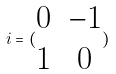Convert formula to latex. <formula><loc_0><loc_0><loc_500><loc_500>i = ( \begin{matrix} 0 & - 1 \\ 1 & 0 \end{matrix} )</formula> 